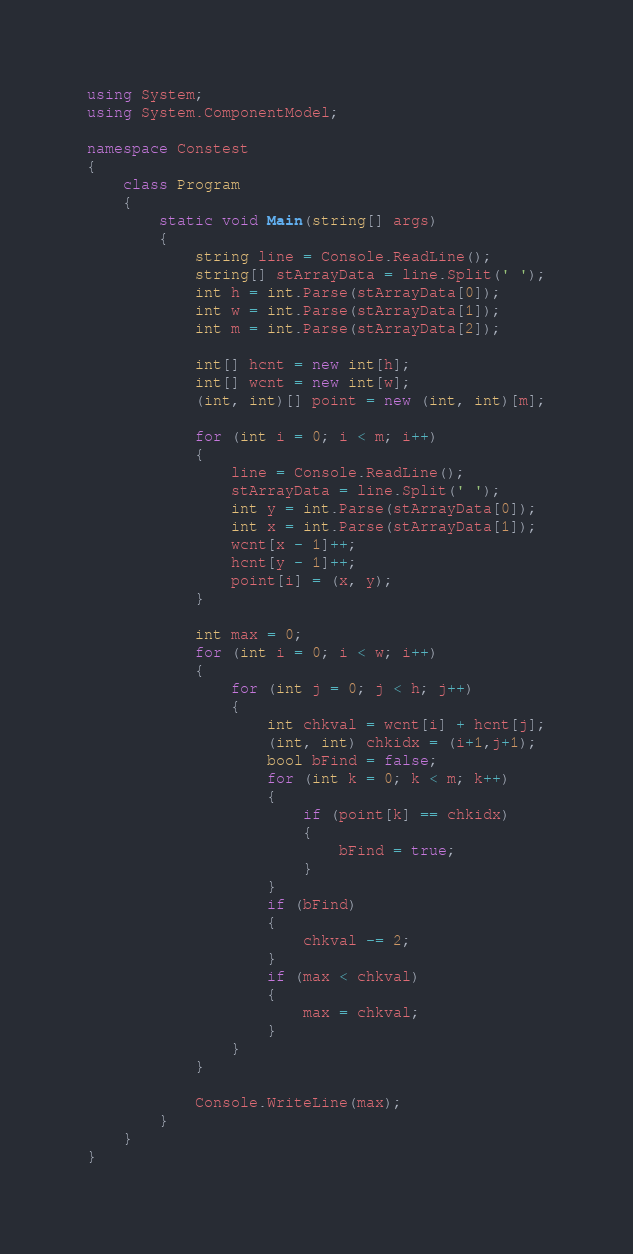<code> <loc_0><loc_0><loc_500><loc_500><_C#_>using System;
using System.ComponentModel;

namespace Constest
{
    class Program
    {
        static void Main(string[] args)
        {
            string line = Console.ReadLine();
            string[] stArrayData = line.Split(' ');
            int h = int.Parse(stArrayData[0]);
            int w = int.Parse(stArrayData[1]);
            int m = int.Parse(stArrayData[2]);

            int[] hcnt = new int[h];
            int[] wcnt = new int[w];
            (int, int)[] point = new (int, int)[m];

            for (int i = 0; i < m; i++)
            {
                line = Console.ReadLine();
                stArrayData = line.Split(' ');
                int y = int.Parse(stArrayData[0]);
                int x = int.Parse(stArrayData[1]);
                wcnt[x - 1]++;
                hcnt[y - 1]++;
                point[i] = (x, y);
            }

            int max = 0;
            for (int i = 0; i < w; i++)
            {
                for (int j = 0; j < h; j++)
                {
                    int chkval = wcnt[i] + hcnt[j];
                    (int, int) chkidx = (i+1,j+1);
                    bool bFind = false;
                    for (int k = 0; k < m; k++)
                    {
                        if (point[k] == chkidx)
                        {
                            bFind = true;
                        }
                    }
                    if (bFind)
                    {
                        chkval -= 2;
                    }
                    if (max < chkval)
                    {
                        max = chkval;
                    }
                }
            }          

            Console.WriteLine(max);
        }
    }
}
</code> 